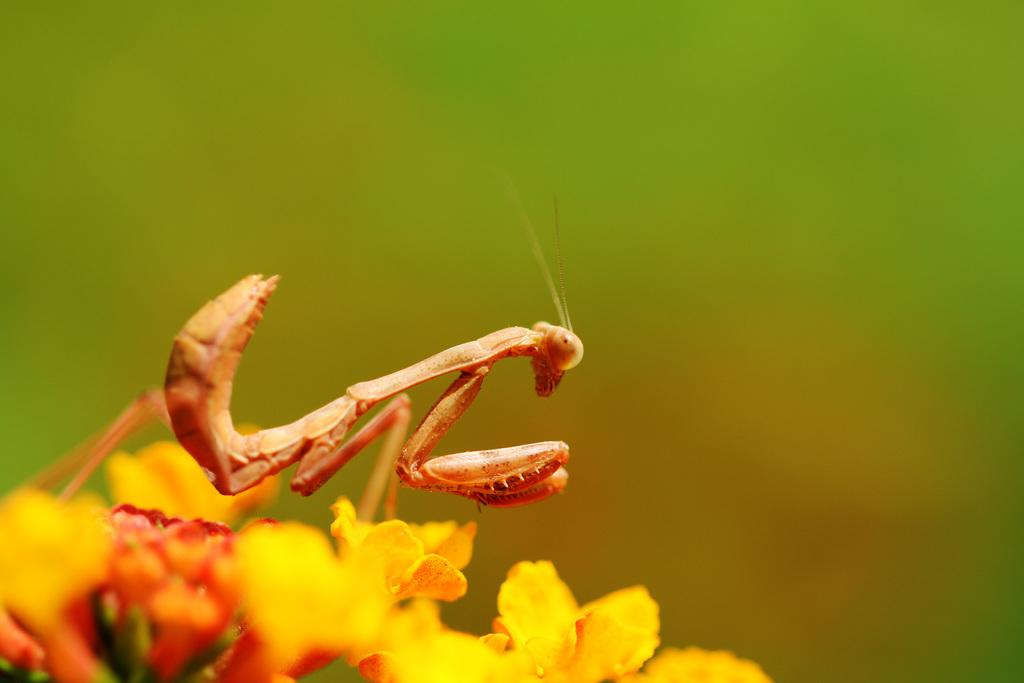What type of creature can be seen in the image? There is an insect in the image. What other living organisms are present in the image? There are flowers in the image. How would you describe the background of the image? The background of the image has a blurred view. Can you see any signs of an earthquake in the image? There is no indication of an earthquake in the image. Is there a chessboard visible in the image? There is no chessboard present in the image. 